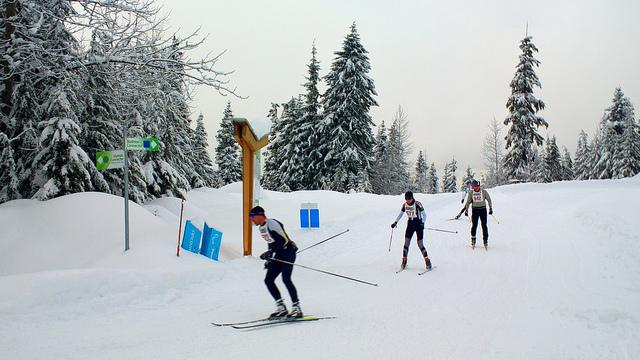Where was modern skiing invented?

Choices:
A) switzerland
B) russia
C) china
D) scandinavia scandinavia 